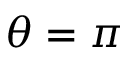<formula> <loc_0><loc_0><loc_500><loc_500>\theta = \pi</formula> 